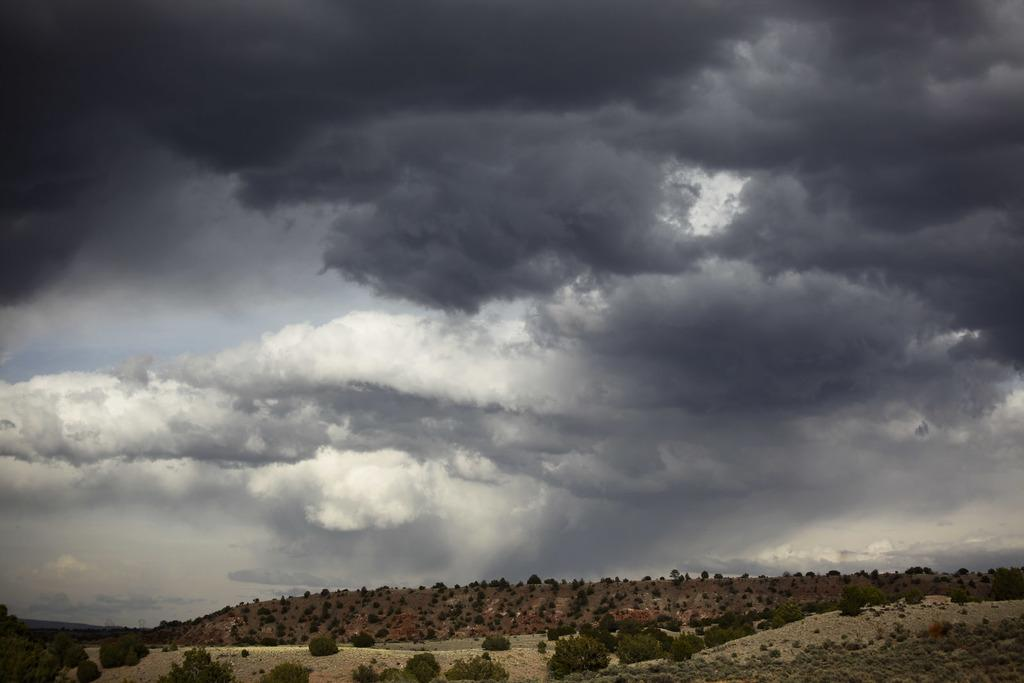What type of natural elements can be seen in the image? There are trees and hills visible in the image. What is visible in the background of the image? The sky is visible in the image. What can be observed in the sky? Clouds are present in the sky. What type of sound can be heard coming from the trees in the image? There is no sound present in the image, as it is a still photograph. 